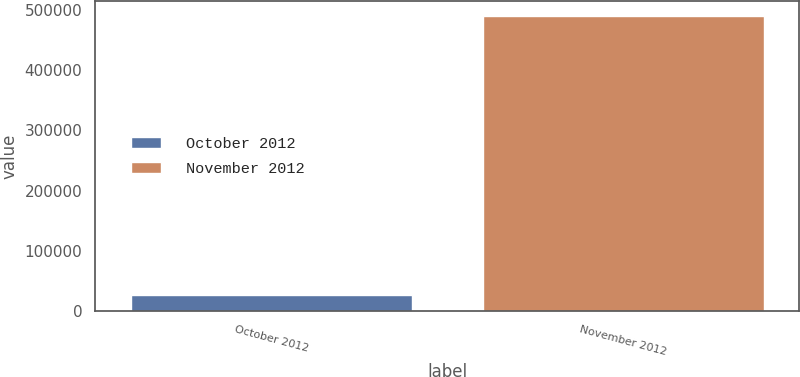<chart> <loc_0><loc_0><loc_500><loc_500><bar_chart><fcel>October 2012<fcel>November 2012<nl><fcel>27524<fcel>489390<nl></chart> 